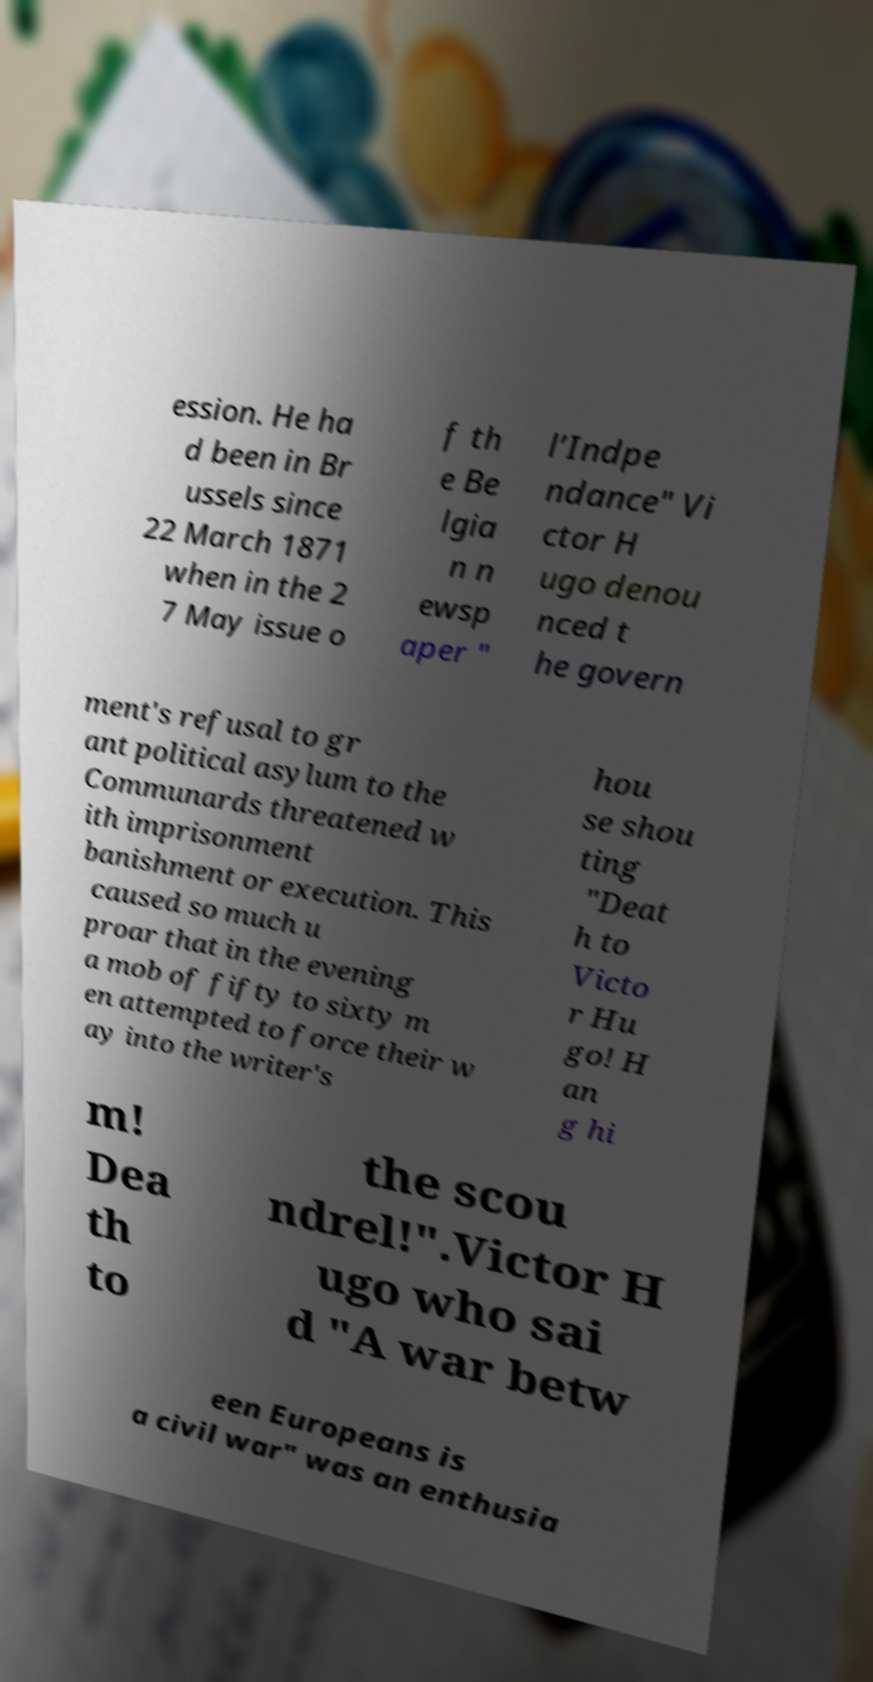Please identify and transcribe the text found in this image. ession. He ha d been in Br ussels since 22 March 1871 when in the 2 7 May issue o f th e Be lgia n n ewsp aper " l’Indpe ndance" Vi ctor H ugo denou nced t he govern ment's refusal to gr ant political asylum to the Communards threatened w ith imprisonment banishment or execution. This caused so much u proar that in the evening a mob of fifty to sixty m en attempted to force their w ay into the writer's hou se shou ting "Deat h to Victo r Hu go! H an g hi m! Dea th to the scou ndrel!".Victor H ugo who sai d "A war betw een Europeans is a civil war" was an enthusia 